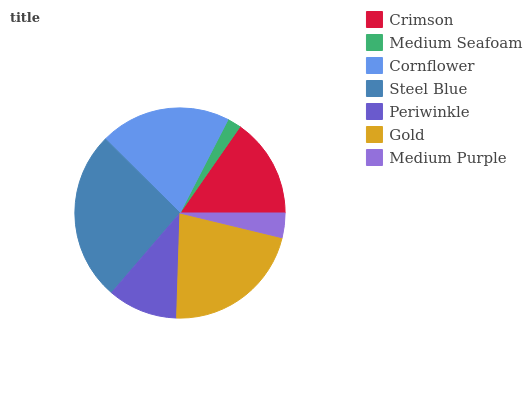Is Medium Seafoam the minimum?
Answer yes or no. Yes. Is Steel Blue the maximum?
Answer yes or no. Yes. Is Cornflower the minimum?
Answer yes or no. No. Is Cornflower the maximum?
Answer yes or no. No. Is Cornflower greater than Medium Seafoam?
Answer yes or no. Yes. Is Medium Seafoam less than Cornflower?
Answer yes or no. Yes. Is Medium Seafoam greater than Cornflower?
Answer yes or no. No. Is Cornflower less than Medium Seafoam?
Answer yes or no. No. Is Crimson the high median?
Answer yes or no. Yes. Is Crimson the low median?
Answer yes or no. Yes. Is Steel Blue the high median?
Answer yes or no. No. Is Medium Purple the low median?
Answer yes or no. No. 